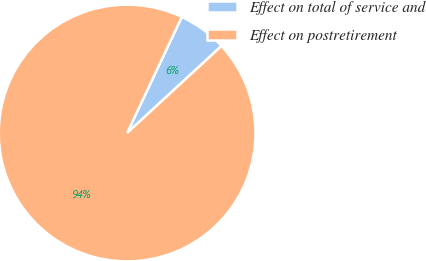Convert chart to OTSL. <chart><loc_0><loc_0><loc_500><loc_500><pie_chart><fcel>Effect on total of service and<fcel>Effect on postretirement<nl><fcel>6.14%<fcel>93.86%<nl></chart> 